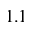<formula> <loc_0><loc_0><loc_500><loc_500>1 . 1</formula> 